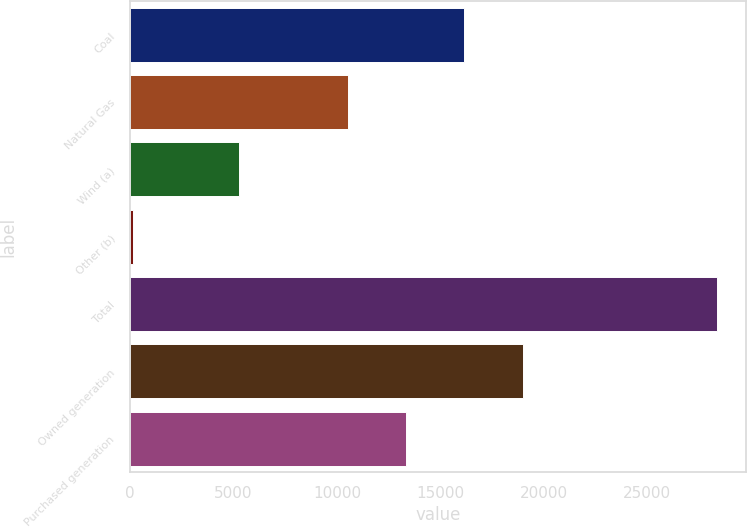<chart> <loc_0><loc_0><loc_500><loc_500><bar_chart><fcel>Coal<fcel>Natural Gas<fcel>Wind (a)<fcel>Other (b)<fcel>Total<fcel>Owned generation<fcel>Purchased generation<nl><fcel>16155.4<fcel>10514<fcel>5252<fcel>150<fcel>28357<fcel>18976.1<fcel>13334.7<nl></chart> 